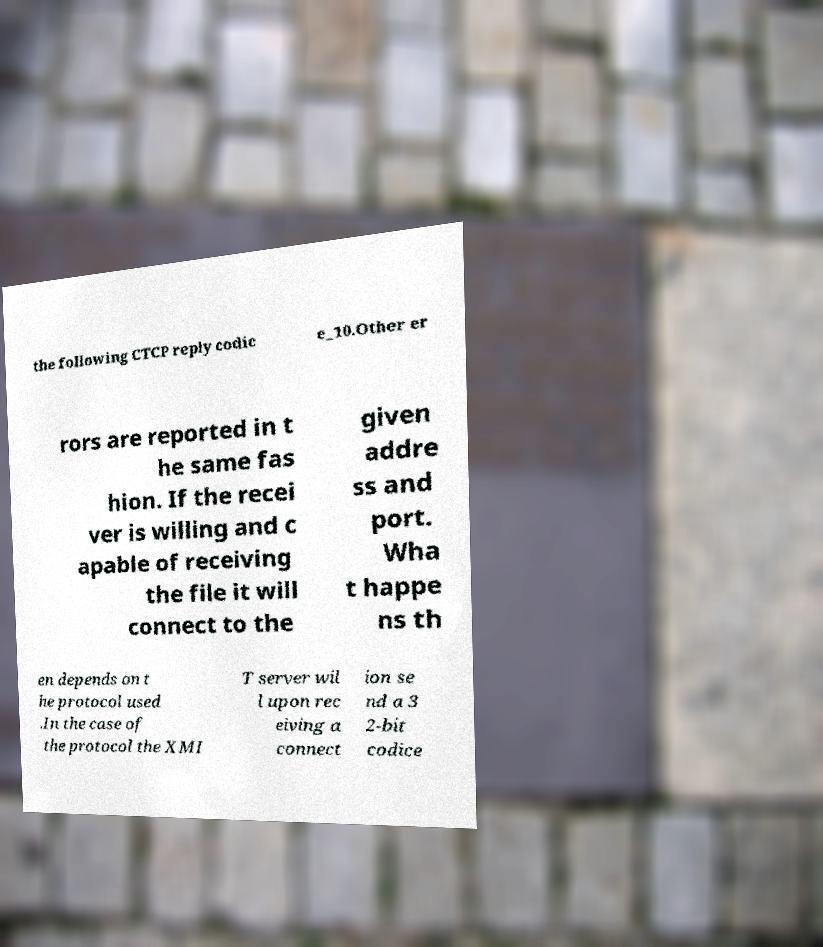Can you read and provide the text displayed in the image?This photo seems to have some interesting text. Can you extract and type it out for me? the following CTCP reply codic e_10.Other er rors are reported in t he same fas hion. If the recei ver is willing and c apable of receiving the file it will connect to the given addre ss and port. Wha t happe ns th en depends on t he protocol used .In the case of the protocol the XMI T server wil l upon rec eiving a connect ion se nd a 3 2-bit codice 